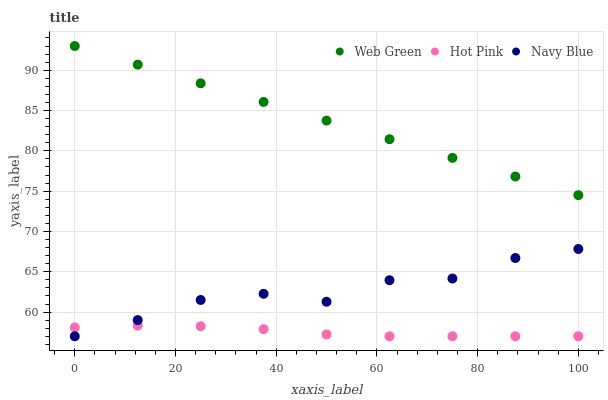Does Hot Pink have the minimum area under the curve?
Answer yes or no. Yes. Does Web Green have the maximum area under the curve?
Answer yes or no. Yes. Does Web Green have the minimum area under the curve?
Answer yes or no. No. Does Hot Pink have the maximum area under the curve?
Answer yes or no. No. Is Web Green the smoothest?
Answer yes or no. Yes. Is Navy Blue the roughest?
Answer yes or no. Yes. Is Hot Pink the smoothest?
Answer yes or no. No. Is Hot Pink the roughest?
Answer yes or no. No. Does Navy Blue have the lowest value?
Answer yes or no. Yes. Does Web Green have the lowest value?
Answer yes or no. No. Does Web Green have the highest value?
Answer yes or no. Yes. Does Hot Pink have the highest value?
Answer yes or no. No. Is Navy Blue less than Web Green?
Answer yes or no. Yes. Is Web Green greater than Hot Pink?
Answer yes or no. Yes. Does Navy Blue intersect Hot Pink?
Answer yes or no. Yes. Is Navy Blue less than Hot Pink?
Answer yes or no. No. Is Navy Blue greater than Hot Pink?
Answer yes or no. No. Does Navy Blue intersect Web Green?
Answer yes or no. No. 